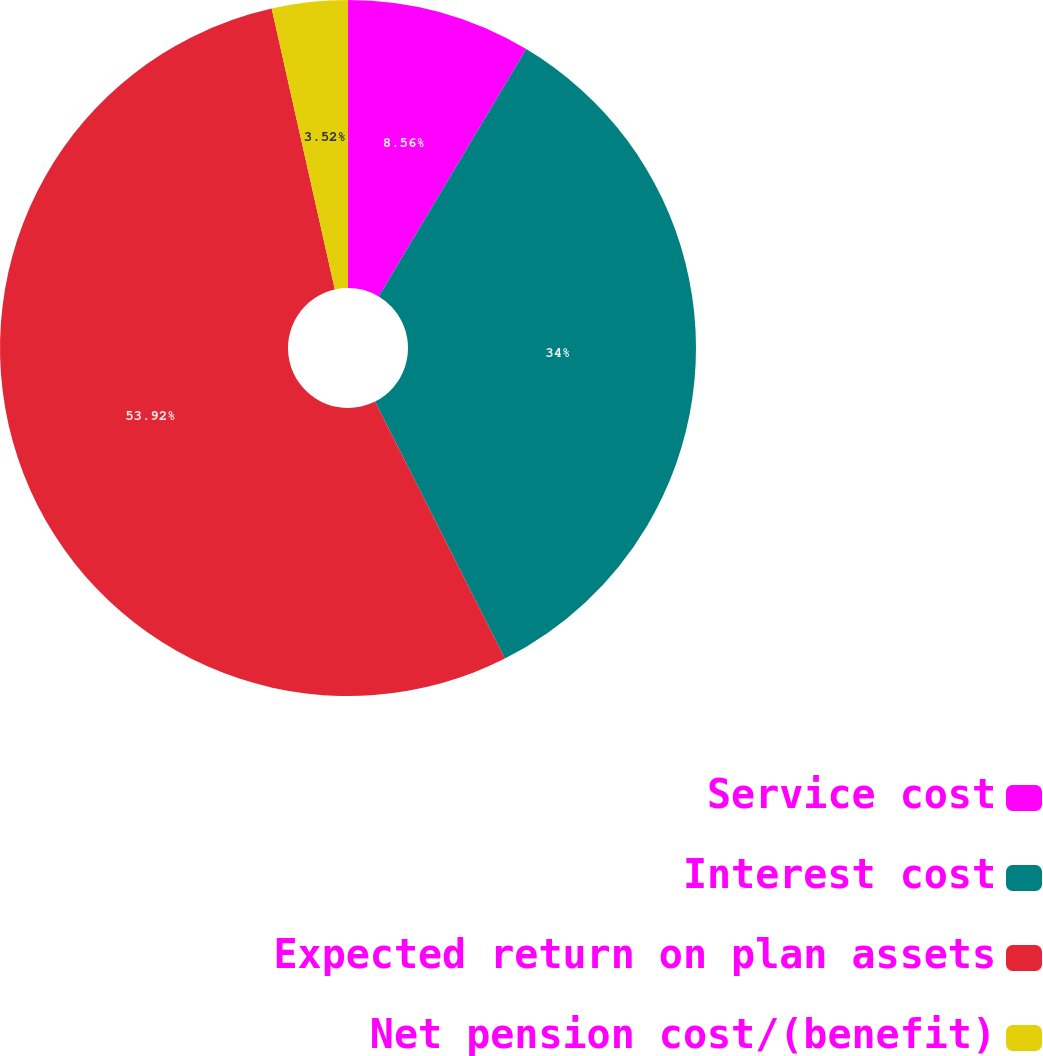<chart> <loc_0><loc_0><loc_500><loc_500><pie_chart><fcel>Service cost<fcel>Interest cost<fcel>Expected return on plan assets<fcel>Net pension cost/(benefit)<nl><fcel>8.56%<fcel>34.0%<fcel>53.93%<fcel>3.52%<nl></chart> 